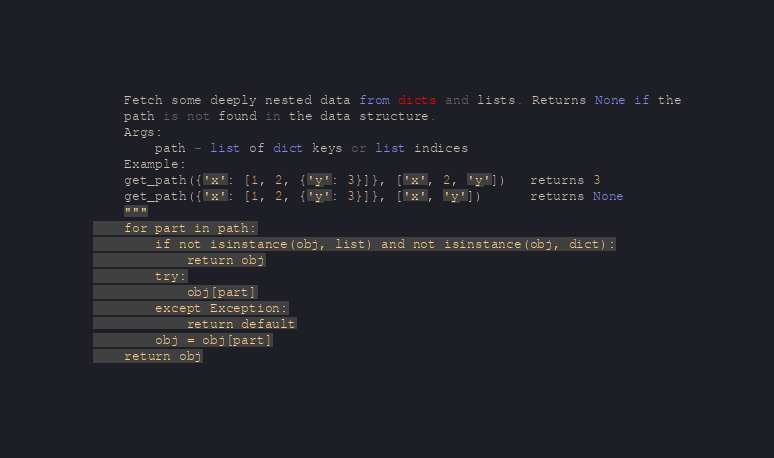Convert code to text. <code><loc_0><loc_0><loc_500><loc_500><_Python_>    Fetch some deeply nested data from dicts and lists. Returns None if the
    path is not found in the data structure.
    Args:
        path - list of dict keys or list indices
    Example:
    get_path({'x': [1, 2, {'y': 3}]}, ['x', 2, 'y'])   returns 3
    get_path({'x': [1, 2, {'y': 3}]}, ['x', 'y'])      returns None
    """
    for part in path:
        if not isinstance(obj, list) and not isinstance(obj, dict):
            return obj
        try:
            obj[part]
        except Exception:
            return default
        obj = obj[part]
    return obj
</code> 